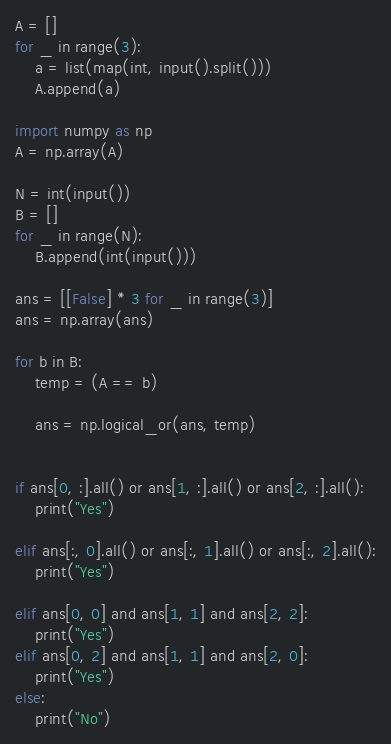<code> <loc_0><loc_0><loc_500><loc_500><_Python_>A = []
for _ in range(3):
    a = list(map(int, input().split()))
    A.append(a)

import numpy as np
A = np.array(A)

N = int(input())
B = []
for _ in range(N):
    B.append(int(input()))

ans = [[False] * 3 for _ in range(3)]
ans = np.array(ans)

for b in B:
    temp = (A == b)

    ans = np.logical_or(ans, temp)


if ans[0, :].all() or ans[1, :].all() or ans[2, :].all():
    print("Yes")

elif ans[:, 0].all() or ans[:, 1].all() or ans[:, 2].all():
    print("Yes")

elif ans[0, 0] and ans[1, 1] and ans[2, 2]:
    print("Yes")
elif ans[0, 2] and ans[1, 1] and ans[2, 0]:
    print("Yes")
else:
    print("No")


</code> 